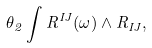<formula> <loc_0><loc_0><loc_500><loc_500>\theta _ { 2 } \int R ^ { I J } ( \omega ) \wedge R _ { I J } ,</formula> 